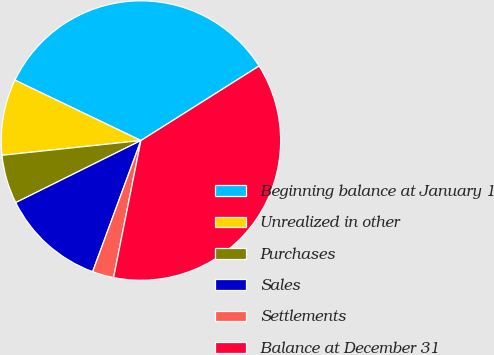Convert chart. <chart><loc_0><loc_0><loc_500><loc_500><pie_chart><fcel>Beginning balance at January 1<fcel>Unrealized in other<fcel>Purchases<fcel>Sales<fcel>Settlements<fcel>Balance at December 31<nl><fcel>33.93%<fcel>8.8%<fcel>5.64%<fcel>12.06%<fcel>2.48%<fcel>37.09%<nl></chart> 